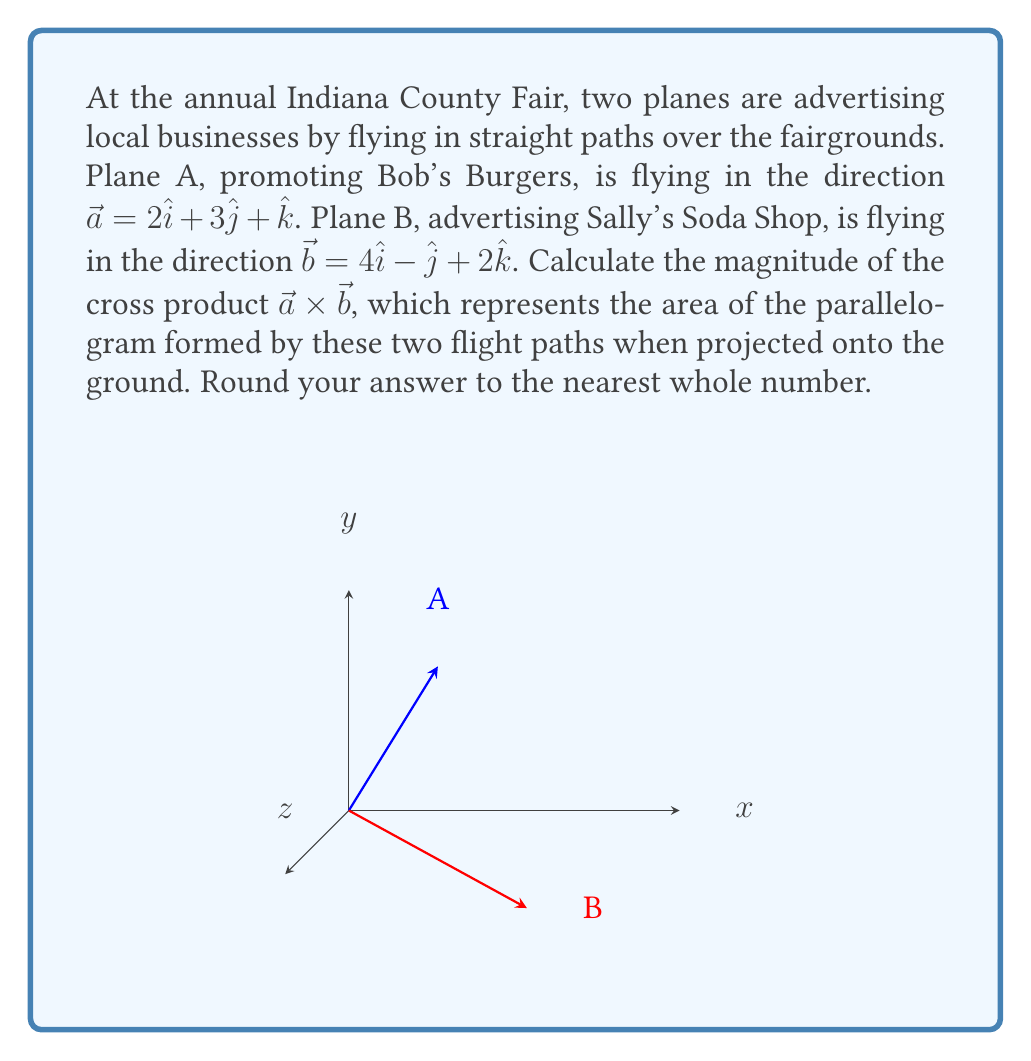Help me with this question. Let's approach this step-by-step:

1) The cross product of two vectors $\vec{a} = (a_1, a_2, a_3)$ and $\vec{b} = (b_1, b_2, b_3)$ is given by:

   $$\vec{a} \times \vec{b} = (a_2b_3 - a_3b_2)\hat{i} - (a_1b_3 - a_3b_1)\hat{j} + (a_1b_2 - a_2b_1)\hat{k}$$

2) In this case, we have:
   $\vec{a} = 2\hat{i} + 3\hat{j} + \hat{k}$
   $\vec{b} = 4\hat{i} - \hat{j} + 2\hat{k}$

3) Let's calculate each component:

   $i$ component: $(3)(2) - (1)(-1) = 6 + 1 = 7$
   $j$ component: $-[(2)(2) - (1)(4)] = -[4 - 4] = 0$
   $k$ component: $(2)(-1) - (3)(4) = -2 - 12 = -14$

4) Therefore, $\vec{a} \times \vec{b} = 7\hat{i} + 0\hat{j} - 14\hat{k}$

5) The magnitude of this cross product is:

   $$|\vec{a} \times \vec{b}| = \sqrt{7^2 + 0^2 + (-14)^2} = \sqrt{49 + 0 + 196} = \sqrt{245}$$

6) $\sqrt{245} \approx 15.65$

7) Rounding to the nearest whole number, we get 16.
Answer: 16 